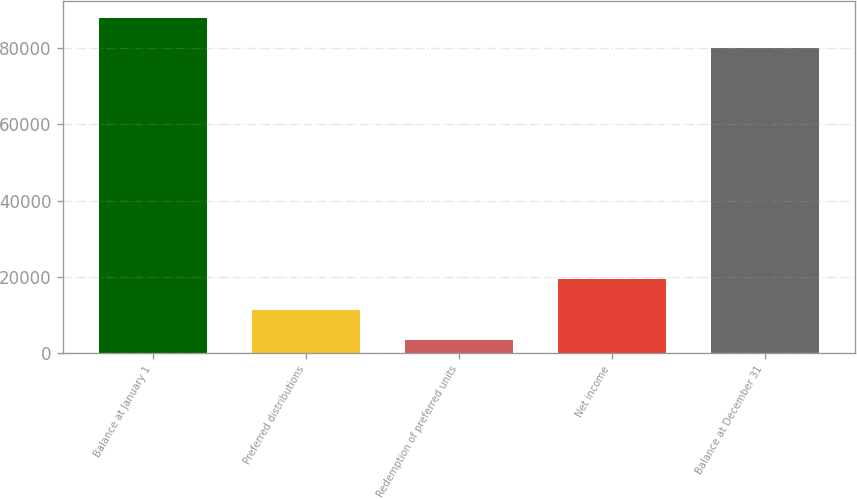<chart> <loc_0><loc_0><loc_500><loc_500><bar_chart><fcel>Balance at January 1<fcel>Preferred distributions<fcel>Redemption of preferred units<fcel>Net income<fcel>Balance at December 31<nl><fcel>88050.6<fcel>11342.6<fcel>3338<fcel>19347.2<fcel>80046<nl></chart> 